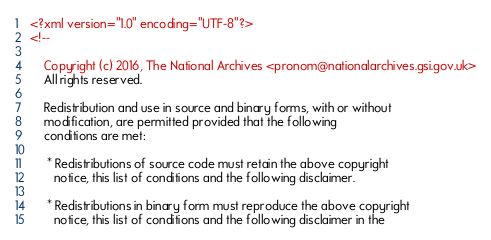<code> <loc_0><loc_0><loc_500><loc_500><_XML_><?xml version="1.0" encoding="UTF-8"?>
<!--

    Copyright (c) 2016, The National Archives <pronom@nationalarchives.gsi.gov.uk>
    All rights reserved.

    Redistribution and use in source and binary forms, with or without
    modification, are permitted provided that the following
    conditions are met:

     * Redistributions of source code must retain the above copyright
       notice, this list of conditions and the following disclaimer.

     * Redistributions in binary form must reproduce the above copyright
       notice, this list of conditions and the following disclaimer in the</code> 